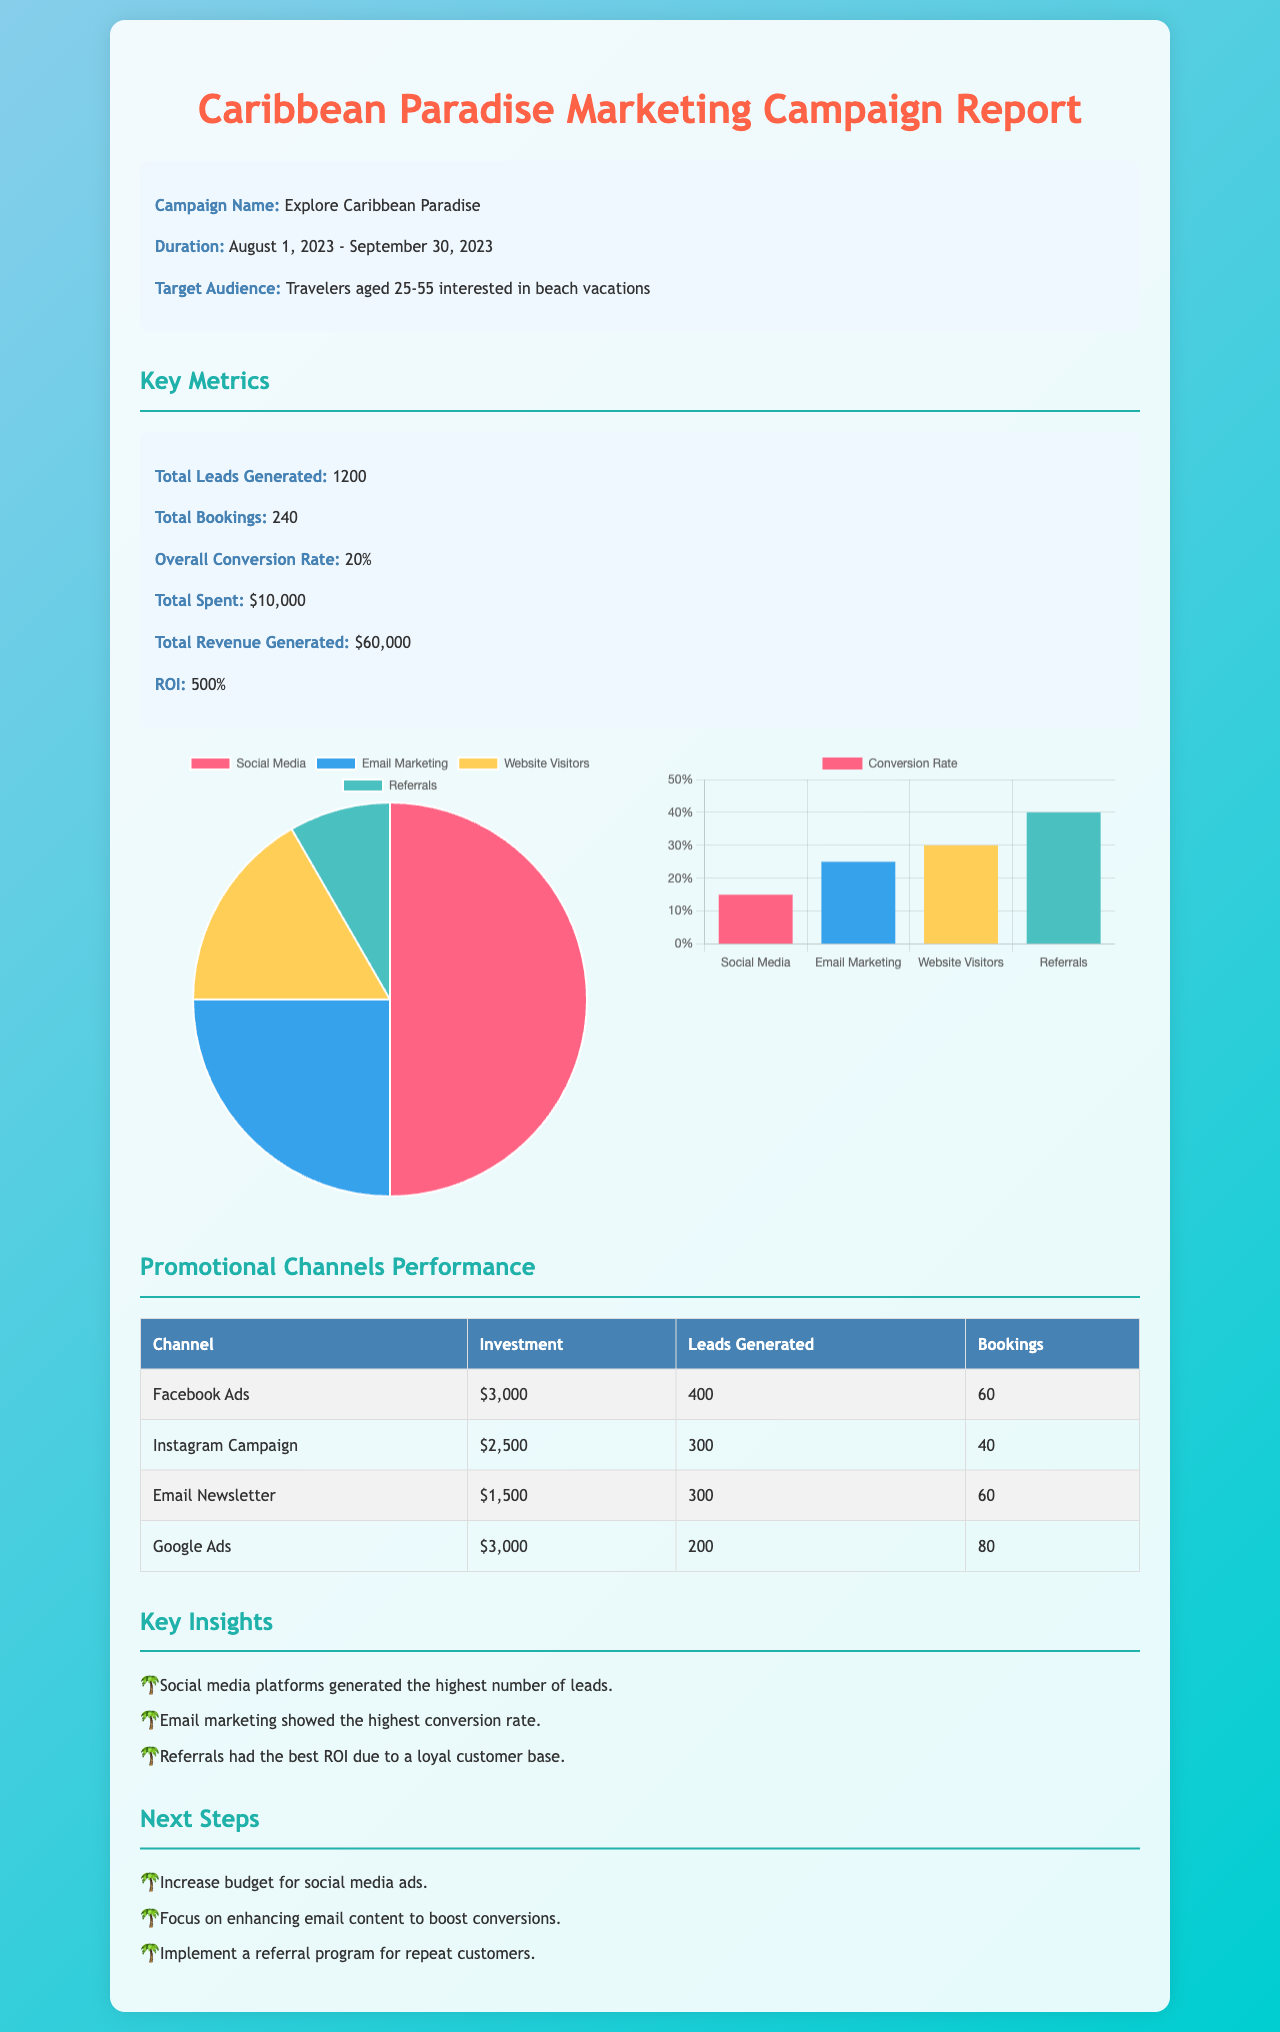what is the campaign name? The campaign name is clearly mentioned at the beginning of the report.
Answer: Explore Caribbean Paradise what is the total amount spent on the campaign? The total amount spent is listed under key metrics in the document.
Answer: $10,000 what is the overall conversion rate? The overall conversion rate can be found in the key metrics section of the report.
Answer: 20% how many total bookings were made? This information is provided in the metrics detailing campaign performance.
Answer: 240 which promotional channel had the highest investment? By reviewing the promotional channels performance table, we can find the channel with the highest investment.
Answer: Facebook Ads what was the total revenue generated? The total revenue generated is included in the key metrics section of the report.
Answer: $60,000 which channel generated the most leads? The number of leads generated by each channel is listed in the promotional channels performance table.
Answer: Facebook Ads what was the ROI for the marketing campaign? The ROI can be found in the key metrics section of the report, summarizing campaign effectiveness.
Answer: 500% what is one key insight gained from the campaign? Key insights are summarized towards the end of the document, reflecting campaign outcomes.
Answer: Social media platforms generated the highest number of leads what is one next step proposed after the campaign? The next steps section outlines future recommendations based on campaign performance.
Answer: Increase budget for social media ads 